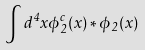<formula> <loc_0><loc_0><loc_500><loc_500>\int d ^ { 4 } x \phi ^ { c } _ { 2 } ( x ) \ast \phi _ { 2 } ( x )</formula> 